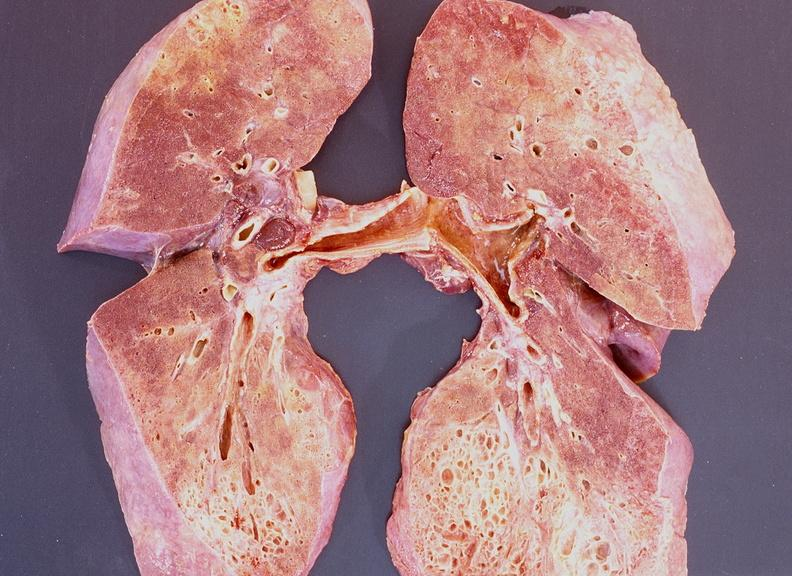what does this image show?
Answer the question using a single word or phrase. Lung fibrosis 